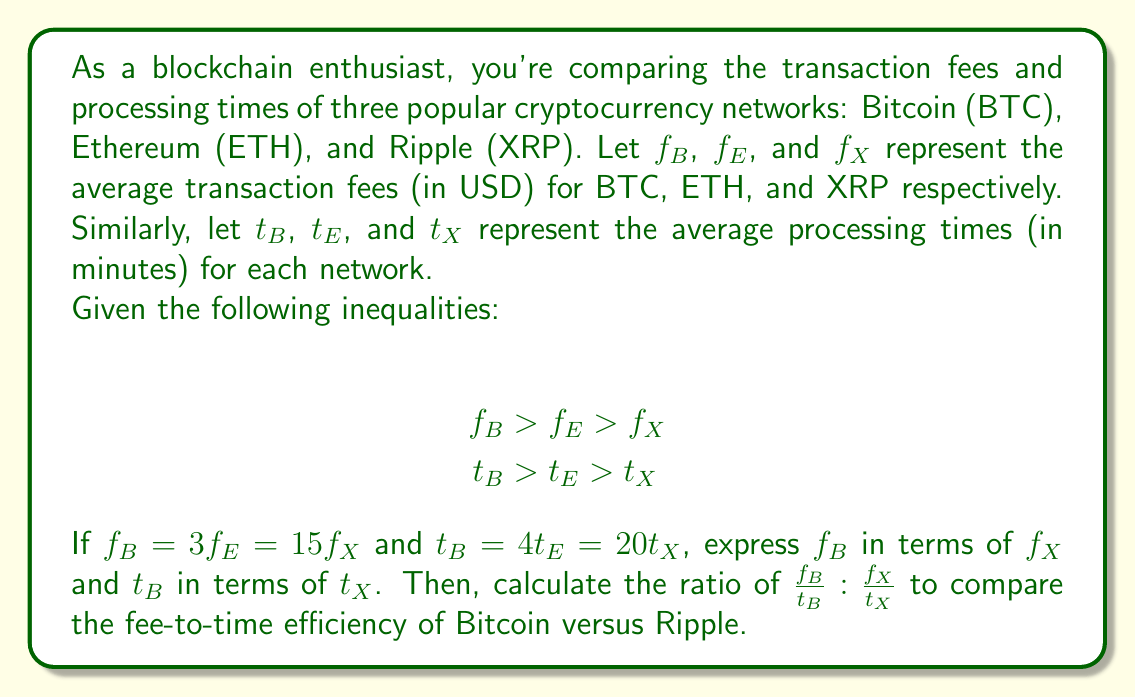Solve this math problem. Let's approach this problem step by step:

1) First, let's express $f_B$ in terms of $f_X$:
   We're given that $f_B = 3f_E$ and $f_B = 15f_X$
   Therefore, $f_B = 15f_X$

2) Now, let's express $t_B$ in terms of $t_X$:
   We're given that $t_B = 4t_E$ and $t_B = 20t_X$
   Therefore, $t_B = 20t_X$

3) Now we need to calculate the ratio $\frac{f_B}{t_B} : \frac{f_X}{t_X}$

   Let's start with $\frac{f_B}{t_B}$:
   $$\frac{f_B}{t_B} = \frac{15f_X}{20t_X} = \frac{3f_X}{4t_X}$$

   For $\frac{f_X}{t_X}$, we don't need to make any changes.

4) Now we can set up our ratio:
   $$\frac{f_B}{t_B} : \frac{f_X}{t_X} = \frac{3f_X}{4t_X} : \frac{f_X}{t_X}$$

5) To simplify this ratio, we can divide both sides by $\frac{f_X}{t_X}$:
   $$\frac{\frac{3f_X}{4t_X}}{\frac{f_X}{t_X}} : \frac{\frac{f_X}{t_X}}{\frac{f_X}{t_X}} = \frac{3}{4} : 1 = 3:4$$

Therefore, the ratio of fee-to-time efficiency of Bitcoin versus Ripple is 3:4.
Answer: The ratio of fee-to-time efficiency of Bitcoin versus Ripple is 3:4. 